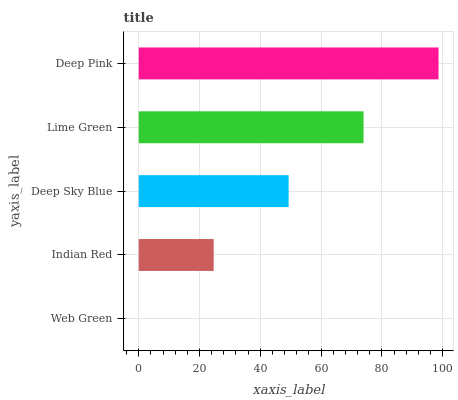Is Web Green the minimum?
Answer yes or no. Yes. Is Deep Pink the maximum?
Answer yes or no. Yes. Is Indian Red the minimum?
Answer yes or no. No. Is Indian Red the maximum?
Answer yes or no. No. Is Indian Red greater than Web Green?
Answer yes or no. Yes. Is Web Green less than Indian Red?
Answer yes or no. Yes. Is Web Green greater than Indian Red?
Answer yes or no. No. Is Indian Red less than Web Green?
Answer yes or no. No. Is Deep Sky Blue the high median?
Answer yes or no. Yes. Is Deep Sky Blue the low median?
Answer yes or no. Yes. Is Lime Green the high median?
Answer yes or no. No. Is Indian Red the low median?
Answer yes or no. No. 